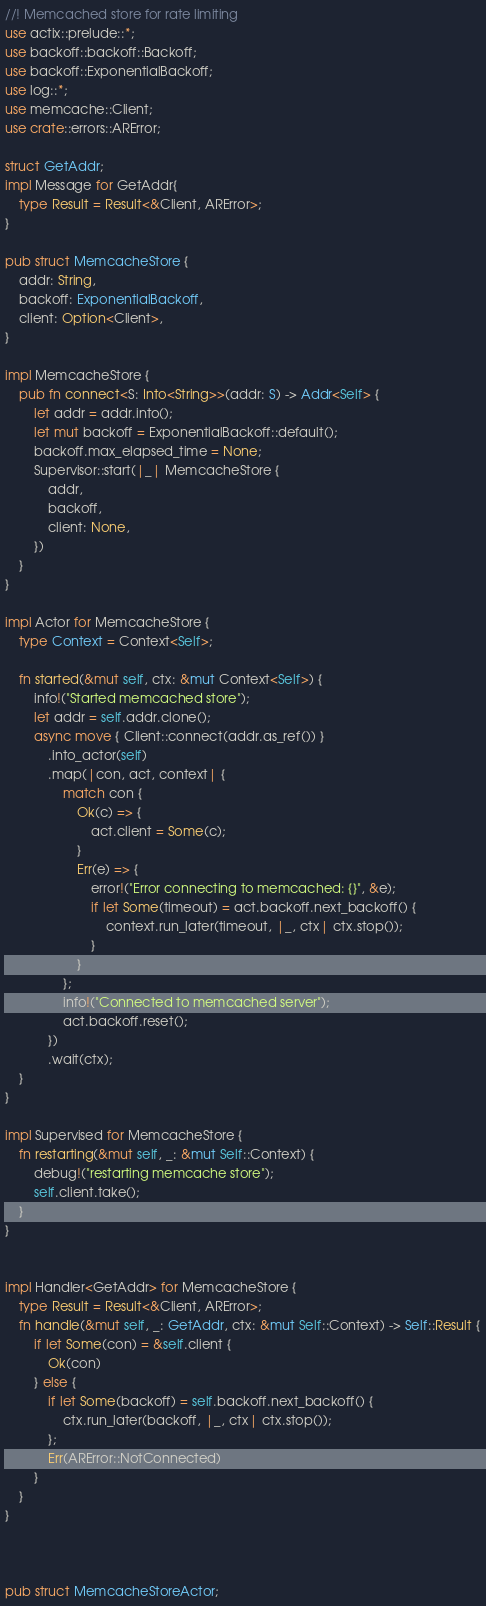Convert code to text. <code><loc_0><loc_0><loc_500><loc_500><_Rust_>//! Memcached store for rate limiting
use actix::prelude::*;
use backoff::backoff::Backoff;
use backoff::ExponentialBackoff;
use log::*;
use memcache::Client;
use crate::errors::ARError;

struct GetAddr;
impl Message for GetAddr{
    type Result = Result<&Client, ARError>;
}

pub struct MemcacheStore {
    addr: String,
    backoff: ExponentialBackoff,
    client: Option<Client>,
}

impl MemcacheStore {
    pub fn connect<S: Into<String>>(addr: S) -> Addr<Self> {
        let addr = addr.into();
        let mut backoff = ExponentialBackoff::default();
        backoff.max_elapsed_time = None;
        Supervisor::start(|_| MemcacheStore {
            addr,
            backoff,
            client: None,
        })
    }
}

impl Actor for MemcacheStore {
    type Context = Context<Self>;

    fn started(&mut self, ctx: &mut Context<Self>) {
        info!("Started memcached store");
        let addr = self.addr.clone();
        async move { Client::connect(addr.as_ref()) }
            .into_actor(self)
            .map(|con, act, context| {
                match con {
                    Ok(c) => {
                        act.client = Some(c);
                    }
                    Err(e) => {
                        error!("Error connecting to memcached: {}", &e);
                        if let Some(timeout) = act.backoff.next_backoff() {
                            context.run_later(timeout, |_, ctx| ctx.stop());
                        }
                    }
                };
                info!("Connected to memcached server");
                act.backoff.reset();
            })
            .wait(ctx);
    }
}

impl Supervised for MemcacheStore {
    fn restarting(&mut self, _: &mut Self::Context) {
        debug!("restarting memcache store");
        self.client.take();
    }
}


impl Handler<GetAddr> for MemcacheStore {
    type Result = Result<&Client, ARError>;
    fn handle(&mut self, _: GetAddr, ctx: &mut Self::Context) -> Self::Result {
        if let Some(con) = &self.client {
            Ok(con)
        } else {
            if let Some(backoff) = self.backoff.next_backoff() {
                ctx.run_later(backoff, |_, ctx| ctx.stop());
            };
            Err(ARError::NotConnected)
        }
    }
}



pub struct MemcacheStoreActor;
</code> 